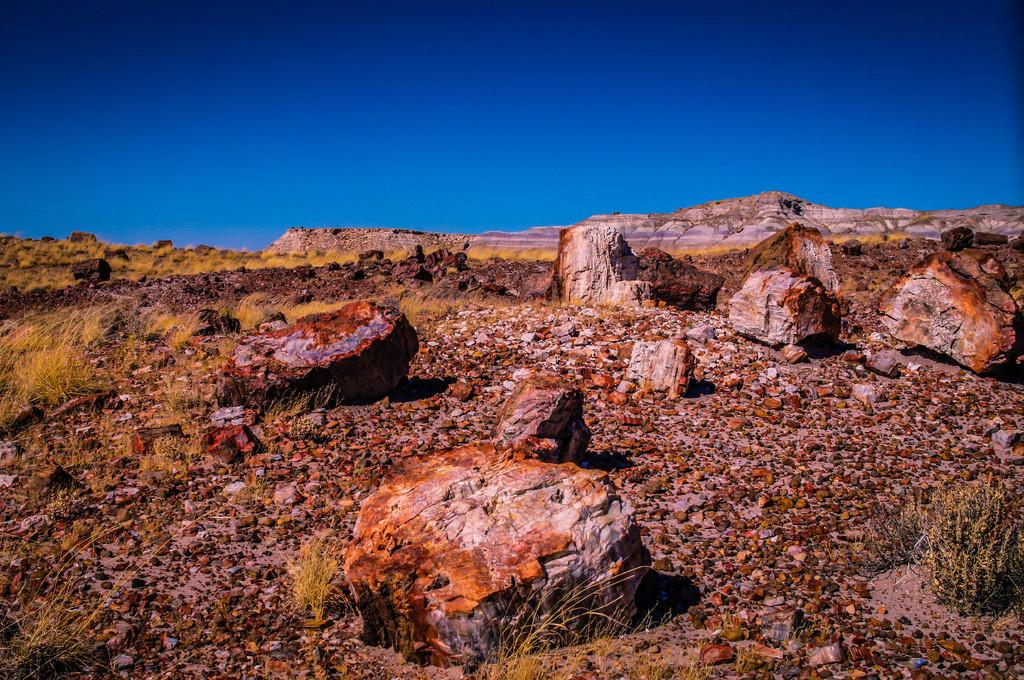Where was the picture taken? The picture was clicked outside. What type of terrain is visible in the foreground of the image? There is grass, gravels, and rocks in the foreground of the image. Are there any other objects present in the foreground of the image? Yes, there are other objects in the foreground of the image. What can be seen in the background of the image? The sky is visible in the background of the image. What type of music can be heard playing in the background of the image? There is no music present in the image, as it is a still photograph. 